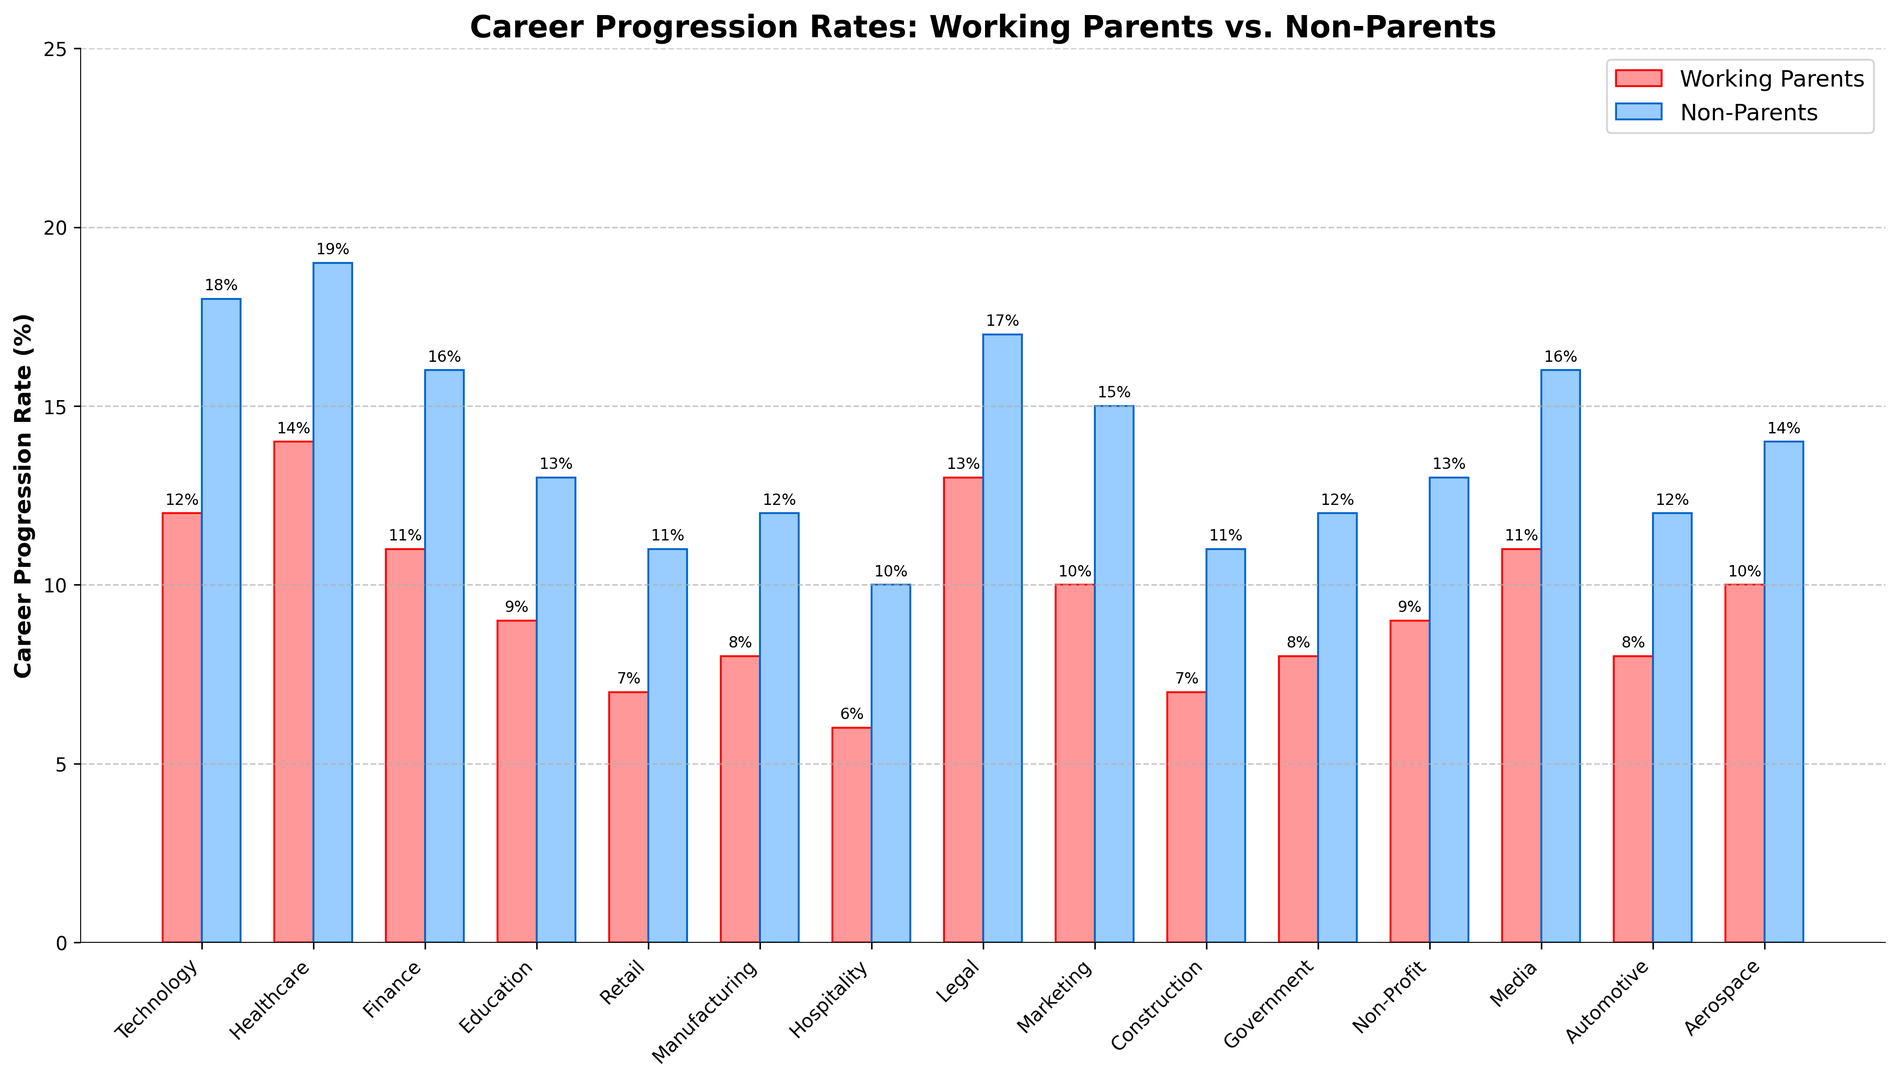Which industry shows the smallest difference in career progression rates between working parents and non-parents? The differences between the career progression rates for each industry are calculated. The smallest difference is found in the construction industry, where the rates are 7% for working parents and 11% for non-parents, resulting in a difference of 4%.
Answer: Construction (4%) Are career progression rates higher for working parents in technology or healthcare? Checking the bar heights for both industries, technology has a rate of 12% for working parents, and healthcare has a rate of 14%. Comparing the two, healthcare has a higher rate.
Answer: Healthcare How much higher is the career progression rate for non-parents compared to working parents in the finance industry? The career progression rate for non-parents in finance is 16%, and for working parents, it is 11%. The difference is calculated as 16% - 11% = 5%.
Answer: 5% In which industry do non-parents have the highest career progression rate, and what is that rate? By visually inspecting the heights of the bars for non-parents, the highest bar is found in healthcare, with a rate of 19%.
Answer: Healthcare (19%) What is the average career progression rate for working parents across all industries? Sum the career progression rates for working parents across all industries, then divide by the number of industries. The rates are (12 + 14 + 11 + 9 + 7 + 8 + 6 + 13 + 10 + 7 + 8 + 9 + 11 + 8 + 10)%. Sum = 143%. There are 15 industries, so the average rate is 143% / 15 = 9.53%.
Answer: 9.53% Which industry has the largest difference in career progression rates between working parents and non-parents? The differences between the career progression rates for each industry are calculated. The largest difference is found in the healthcare industry, where the rates are 14% for working parents and 19% for non-parents, resulting in a difference of 5%.
Answer: Healthcare (5%) In which industries are the career progression rates for working parents below 10%? Checking the bar heights for working parents, industries with rates below 10% are Education (9%), Retail (7%), Manufacturing (8%), Hospitality (6%), Construction (7%), Government (8%), Non-Profit (9%), and Automotive (8%).
Answer: Education, Retail, Manufacturing, Hospitality, Construction, Government, Non-Profit, Automotive Are there any industries where the career progression rate for non-parents is equal to the rate for working parents? By examining the heights of both sets of bars, it is observed that in all industries, the rate for non-parents is higher than that for working parents.
Answer: No What's the difference between the highest and lowest career progression rates for non-parents? The highest career progression rate for non-parents is 19% in healthcare and the lowest is 10% in hospitality. The difference is 19% - 10% = 9%.
Answer: 9% 